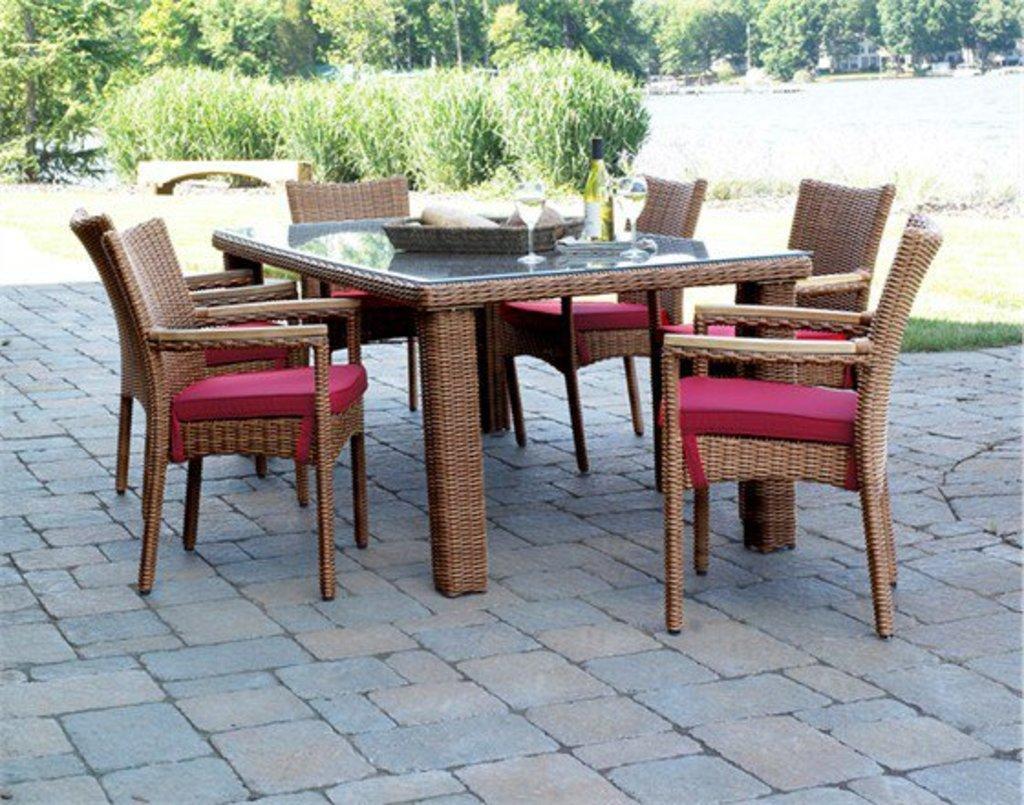In one or two sentences, can you explain what this image depicts? In this image we can see a dining table, tray with beverage bottle and glass tumblers in it and a woven basket. In the background there are bushes, trees, buildings and grass. 